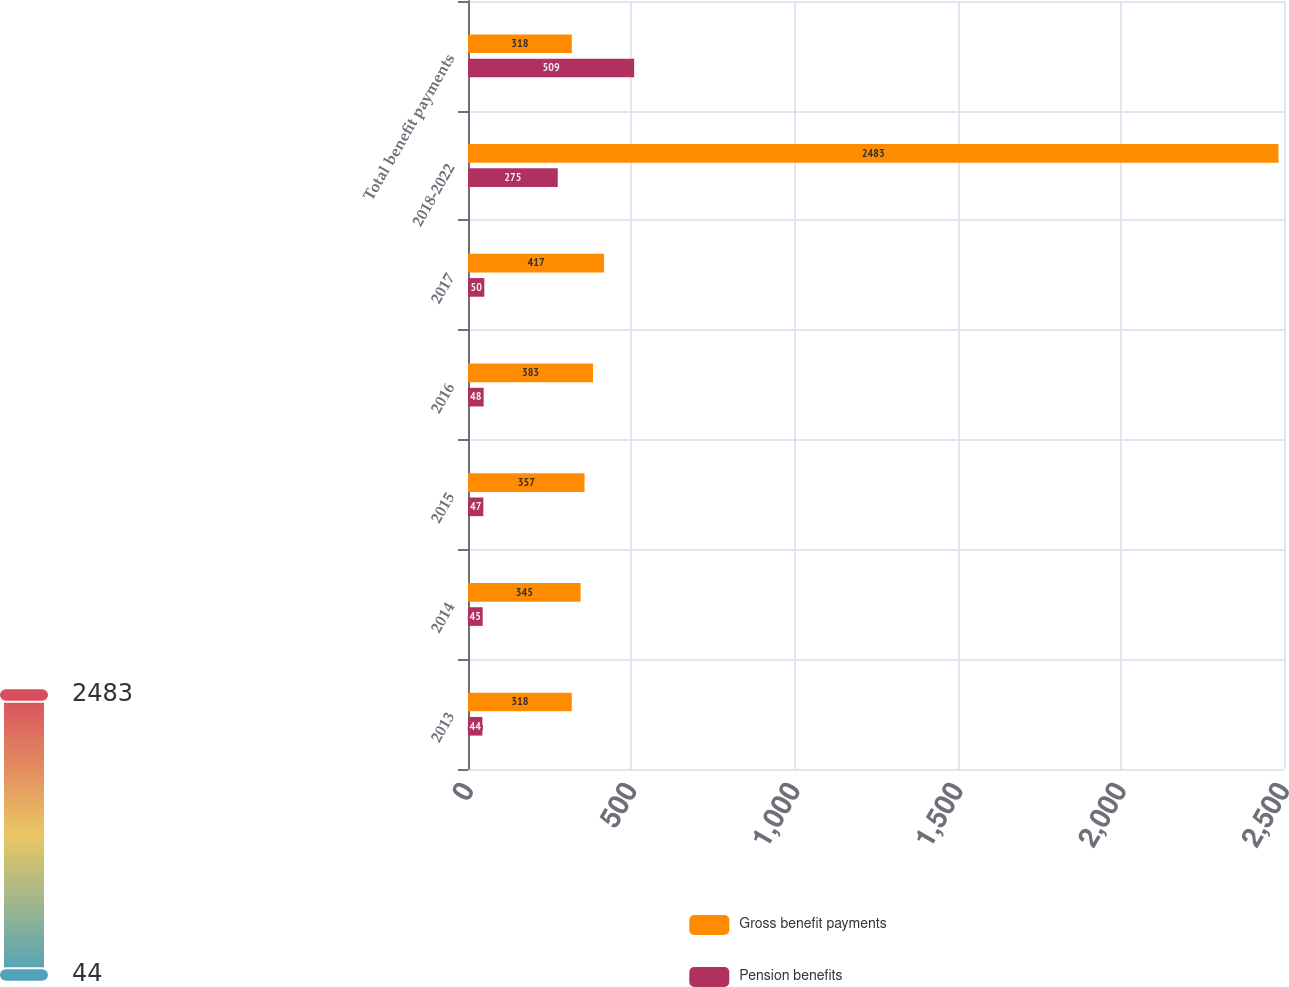Convert chart to OTSL. <chart><loc_0><loc_0><loc_500><loc_500><stacked_bar_chart><ecel><fcel>2013<fcel>2014<fcel>2015<fcel>2016<fcel>2017<fcel>2018-2022<fcel>Total benefit payments<nl><fcel>Gross benefit payments<fcel>318<fcel>345<fcel>357<fcel>383<fcel>417<fcel>2483<fcel>318<nl><fcel>Pension benefits<fcel>44<fcel>45<fcel>47<fcel>48<fcel>50<fcel>275<fcel>509<nl></chart> 